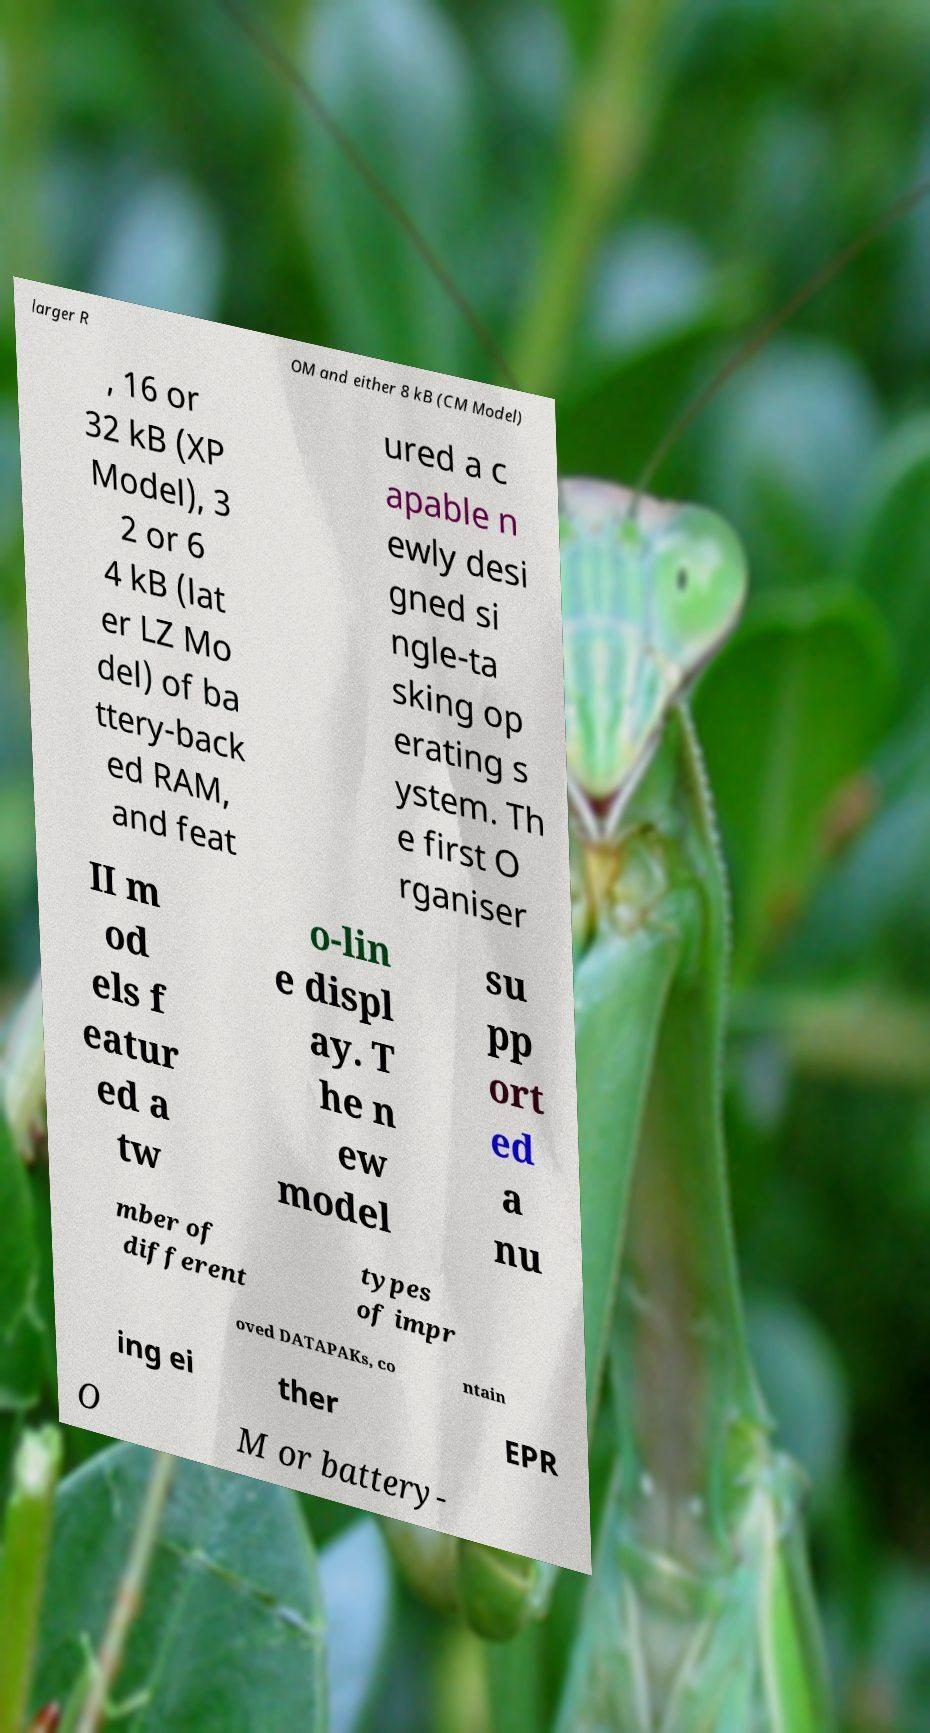For documentation purposes, I need the text within this image transcribed. Could you provide that? larger R OM and either 8 kB (CM Model) , 16 or 32 kB (XP Model), 3 2 or 6 4 kB (lat er LZ Mo del) of ba ttery-back ed RAM, and feat ured a c apable n ewly desi gned si ngle-ta sking op erating s ystem. Th e first O rganiser II m od els f eatur ed a tw o-lin e displ ay. T he n ew model su pp ort ed a nu mber of different types of impr oved DATAPAKs, co ntain ing ei ther EPR O M or battery- 